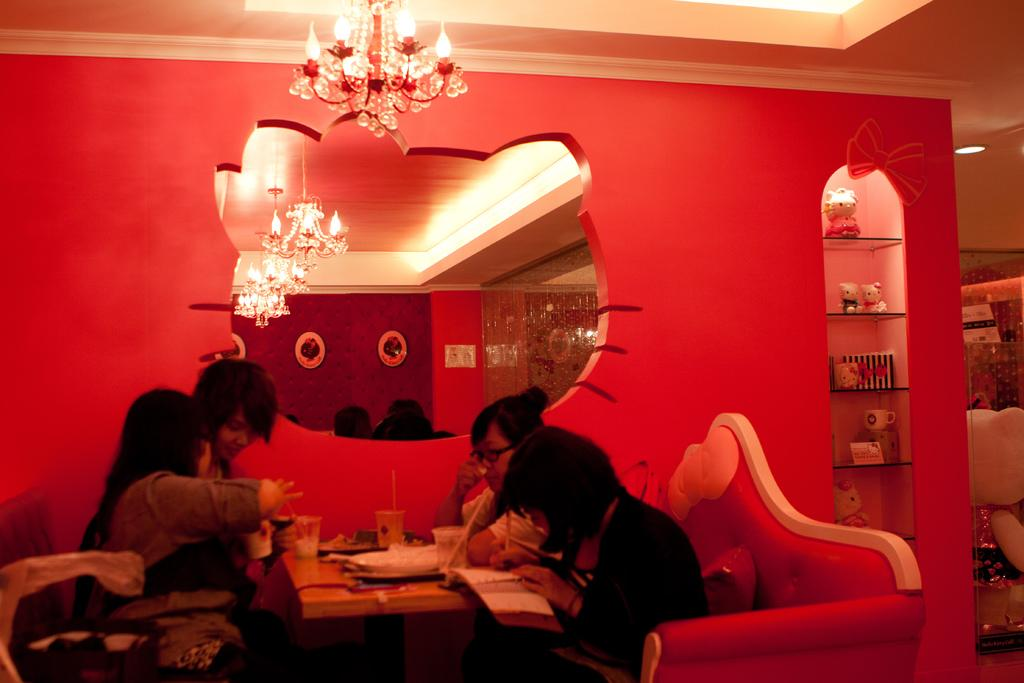How many individuals are present in the image? There are four people in the image. Can you describe any objects or features in the image? Yes, there is a glass mirror on the back side of a table in the image. What is the point of downtown in the image? There is no reference to a downtown area in the image, so it's not possible to determine what the point might be. 